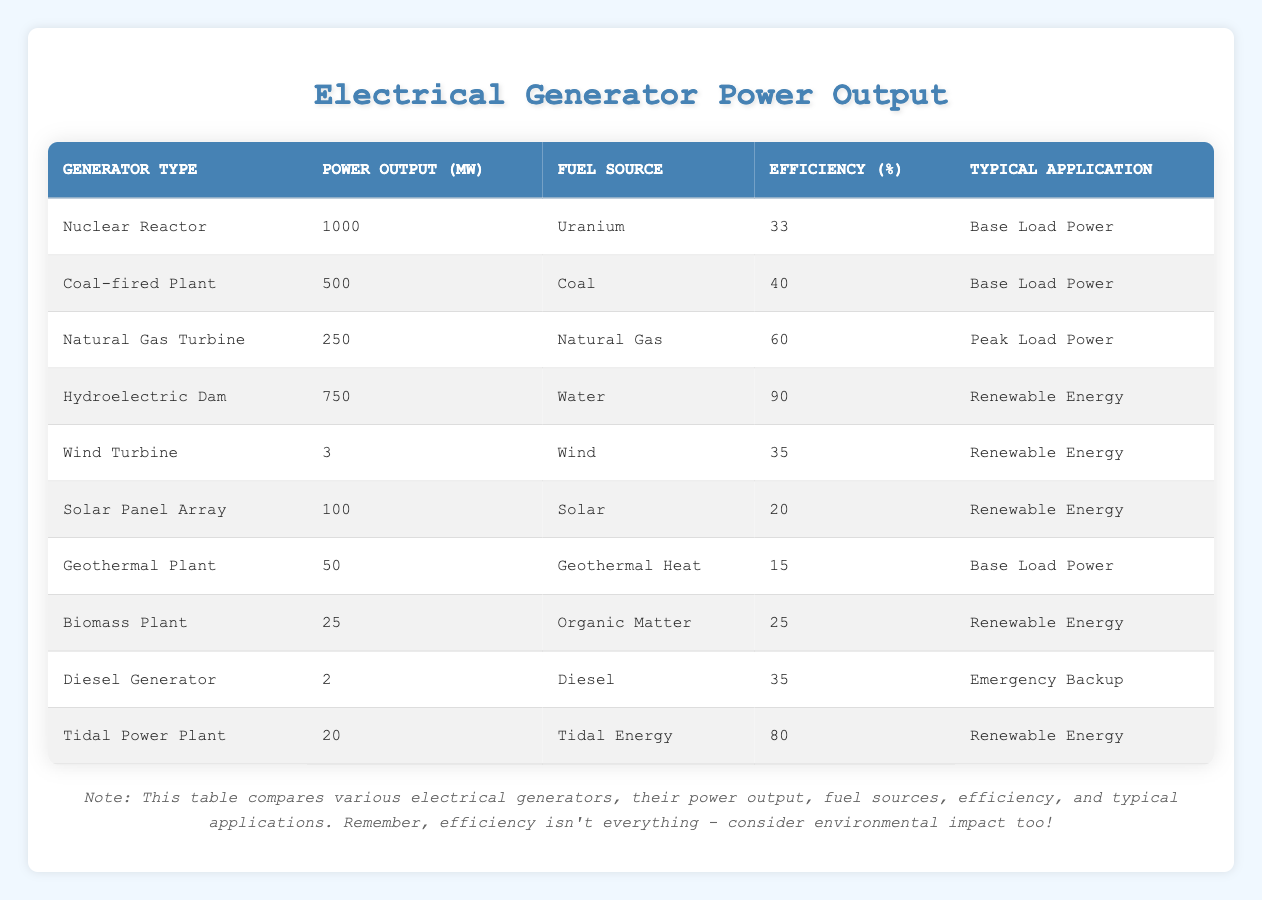What is the power output of the Nuclear Reactor? The table lists the power output of different generators, specifically showing that the Nuclear Reactor produces 1000 MW of power.
Answer: 1000 MW Which generator has the highest efficiency? By examining the efficiency column, the Hydroelectric Dam is noted to have the highest efficiency at 90%.
Answer: 90% How much power does a Wind Turbine generate compared to a Coal-fired Plant? The Wind Turbine generates 3 MW, while the Coal-fired Plant generates 500 MW. To find the difference, we subtract 3 from 500, resulting in 497 MW.
Answer: 497 MW What percentage of power output is provided by Renewable Energy sources in this table? The table includes four types of Renewable Energy sources: Hydroelectric Dam (750 MW), Wind Turbine (3 MW), Solar Panel Array (100 MW), and Biomass Plant (25 MW). Adding these gives us 750 + 3 + 100 + 25 = 878 MW. The total power output from all sources is 1000 + 500 + 250 + 750 + 3 + 100 + 50 + 25 + 2 + 20 = 2670 MW. The percentage of Renewable Energy output is (878 / 2670) * 100 ≈ 32.85%.
Answer: 32.85% Is the efficiency of the Tidal Power Plant greater than 70%? The Tidal Power Plant's efficiency is listed as 80%. Since 80% is greater than 70%, the answer is yes.
Answer: Yes What is the average power output of the Base Load Power generators? The Base Load Power generators are the Nuclear Reactor (1000 MW), Coal-fired Plant (500 MW), and Geothermal Plant (50 MW). Adding these outputs gives us 1000 + 500 + 50 = 1550 MW. There are three Base Load Power generators, so the average is calculated as 1550 / 3 ≈ 516.67 MW.
Answer: 516.67 MW How many generators use organic matter as fuel? The table shows one generator, the Biomass Plant, which uses organic matter as fuel. Therefore, the count is one.
Answer: 1 Which generator produces the least amount of power? Reviewing the power outputs, the Diesel Generator produces the least with 2 MW.
Answer: 2 MW What is the difference in efficiency between Solar Panel Array and Natural Gas Turbine? The Solar Panel Array has an efficiency of 20%, while the Natural Gas Turbine has an efficiency of 60%. The difference in efficiency is calculated as 60 - 20 = 40%.
Answer: 40% 